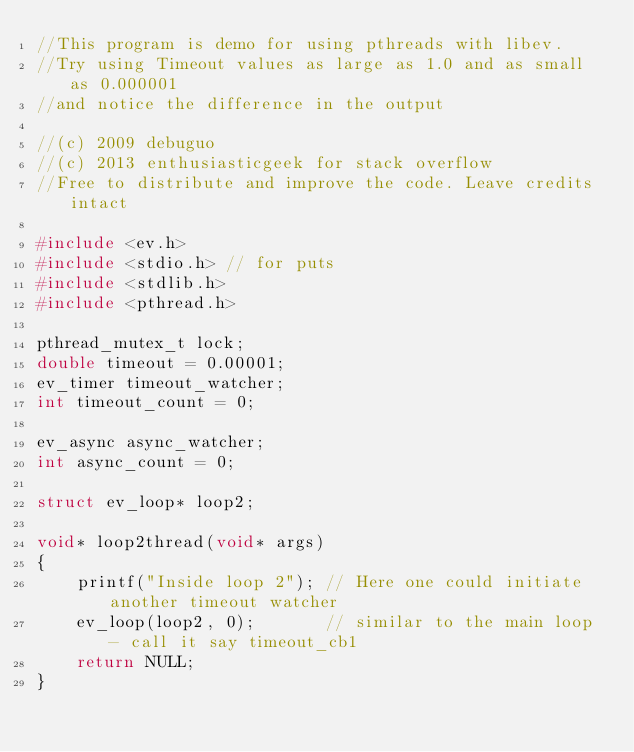Convert code to text. <code><loc_0><loc_0><loc_500><loc_500><_C++_>//This program is demo for using pthreads with libev.
//Try using Timeout values as large as 1.0 and as small as 0.000001
//and notice the difference in the output

//(c) 2009 debuguo
//(c) 2013 enthusiasticgeek for stack overflow
//Free to distribute and improve the code. Leave credits intact

#include <ev.h>
#include <stdio.h> // for puts
#include <stdlib.h>
#include <pthread.h>

pthread_mutex_t lock;
double timeout = 0.00001;
ev_timer timeout_watcher;
int timeout_count = 0;

ev_async async_watcher;
int async_count = 0;

struct ev_loop* loop2;

void* loop2thread(void* args)
{
    printf("Inside loop 2"); // Here one could initiate another timeout watcher
    ev_loop(loop2, 0);       // similar to the main loop - call it say timeout_cb1
    return NULL;
}
</code> 